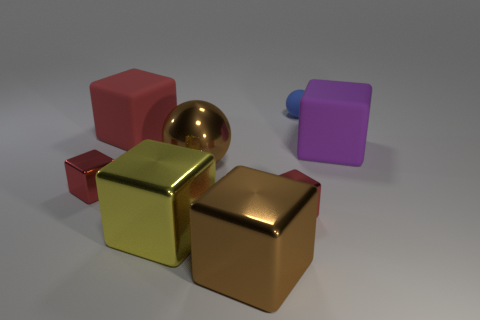How many other objects are there of the same material as the small ball? The small ball appears to be made of a shiny, reflective material, similar to polished metal. Counting the objects with the same material, we observe two larger cubes that share the metallic finish, suggesting they are made of the same material as the small ball. 